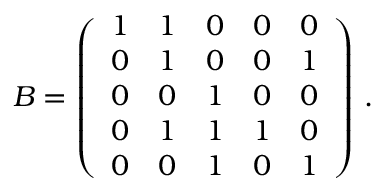<formula> <loc_0><loc_0><loc_500><loc_500>B = \left ( \begin{array} { l l l l l } { 1 } & { 1 } & { 0 } & { 0 } & { 0 } \\ { 0 } & { 1 } & { 0 } & { 0 } & { 1 } \\ { 0 } & { 0 } & { 1 } & { 0 } & { 0 } \\ { 0 } & { 1 } & { 1 } & { 1 } & { 0 } \\ { 0 } & { 0 } & { 1 } & { 0 } & { 1 } \end{array} \right ) \, .</formula> 